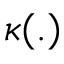<formula> <loc_0><loc_0><loc_500><loc_500>\kappa ( . )</formula> 